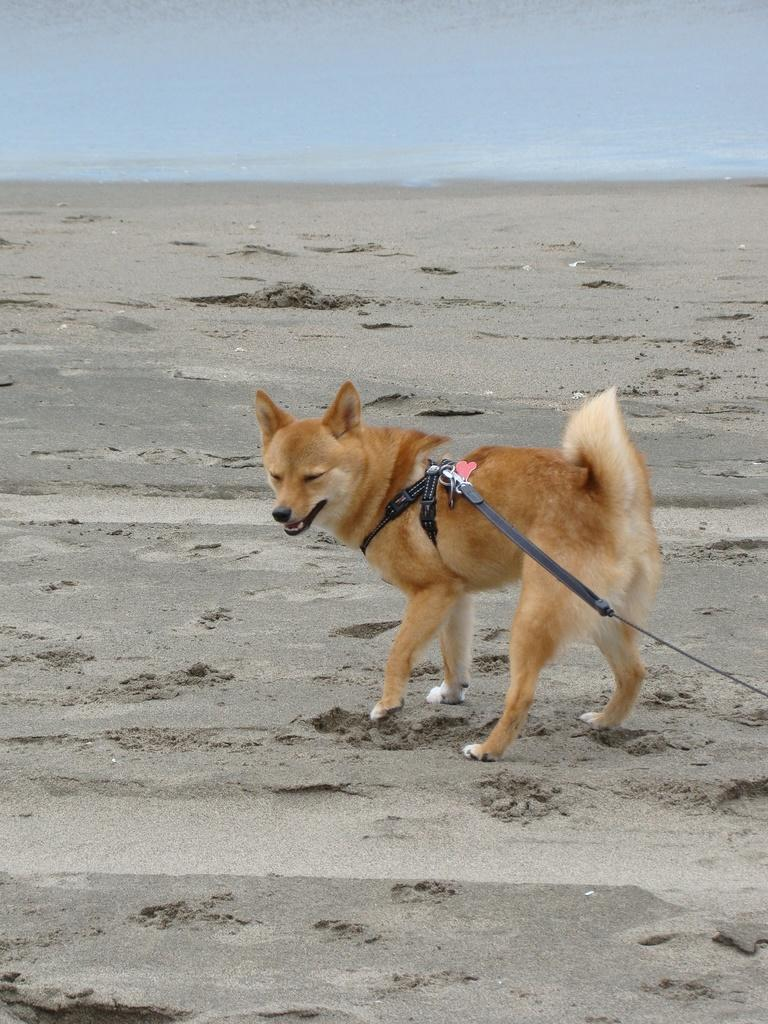What type of animal is in the image? There is a dog in the image. What is the dog wearing? The dog is wearing a belt. What type of surface is visible in the image? There is ground visible in the image. What else can be seen in the image besides the dog? There is water visible in the image. What type of business is being conducted in the image? There is no indication of any business activity in the image; it features a dog wearing a belt in a setting with ground and water. 